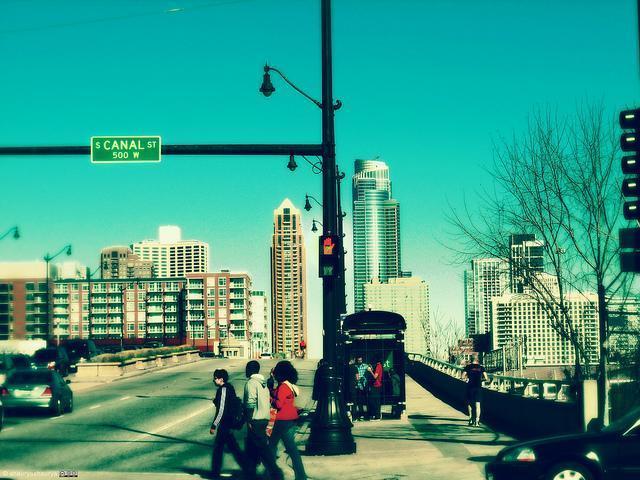How many people are walking across the road?
Give a very brief answer. 3. How many lanes are on the street?
Give a very brief answer. 3. How many cars are in the picture?
Give a very brief answer. 2. How many people are visible?
Give a very brief answer. 3. How many blue keyboards are there?
Give a very brief answer. 0. 